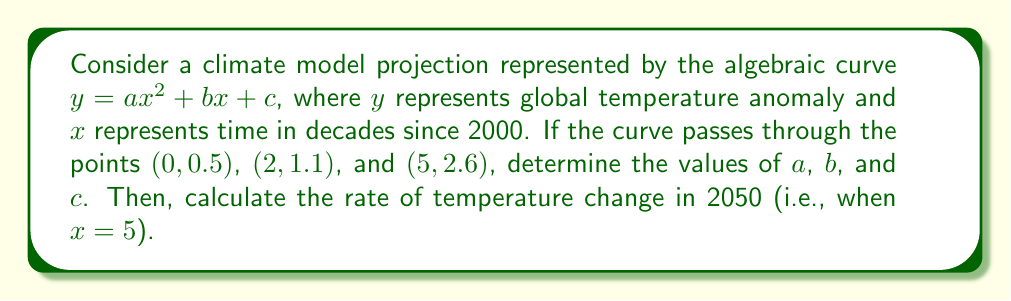What is the answer to this math problem? 1) We have three points that satisfy the equation $y = ax^2 + bx + c$:
   (0, 0.5): $0.5 = a(0)^2 + b(0) + c$, simplifies to $c = 0.5$
   (2, 1.1): $1.1 = a(2)^2 + b(2) + 0.5$
   (5, 2.6): $2.6 = a(5)^2 + b(5) + 0.5$

2) Substitute $c = 0.5$ into the other two equations:
   $0.6 = 4a + 2b$  (equation 1)
   $2.1 = 25a + 5b$ (equation 2)

3) Multiply equation 1 by 5 and equation 2 by -2:
   $3 = 20a + 10b$  (equation 3)
   $-4.2 = -50a - 10b$ (equation 4)

4) Add equations 3 and 4:
   $-1.2 = -30a$
   $a = 0.04$

5) Substitute $a = 0.04$ into equation 1:
   $0.6 = 4(0.04) + 2b$
   $0.6 = 0.16 + 2b$
   $0.44 = 2b$
   $b = 0.22$

6) Therefore, the equation of the curve is:
   $y = 0.04x^2 + 0.22x + 0.5$

7) To find the rate of change in 2050 (x = 5), we need to calculate the derivative:
   $\frac{dy}{dx} = 0.08x + 0.22$

8) Evaluate at x = 5:
   $\frac{dy}{dx}|_{x=5} = 0.08(5) + 0.22 = 0.62$

This means the rate of temperature change in 2050 is 0.62°C per decade.
Answer: 0.62°C/decade 